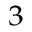Convert formula to latex. <formula><loc_0><loc_0><loc_500><loc_500>^ { 3 }</formula> 